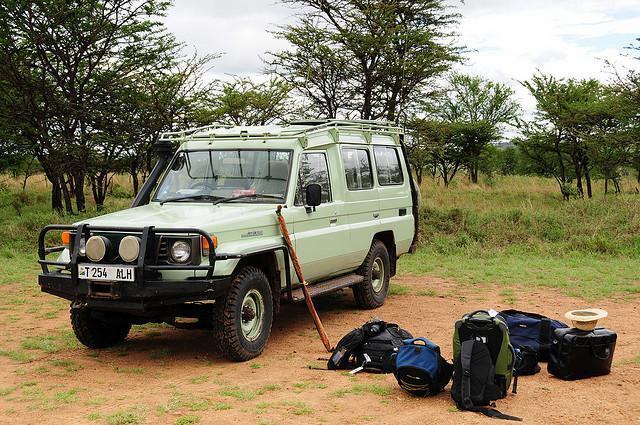How many backpacks are in the photo?
Give a very brief answer. 2. 